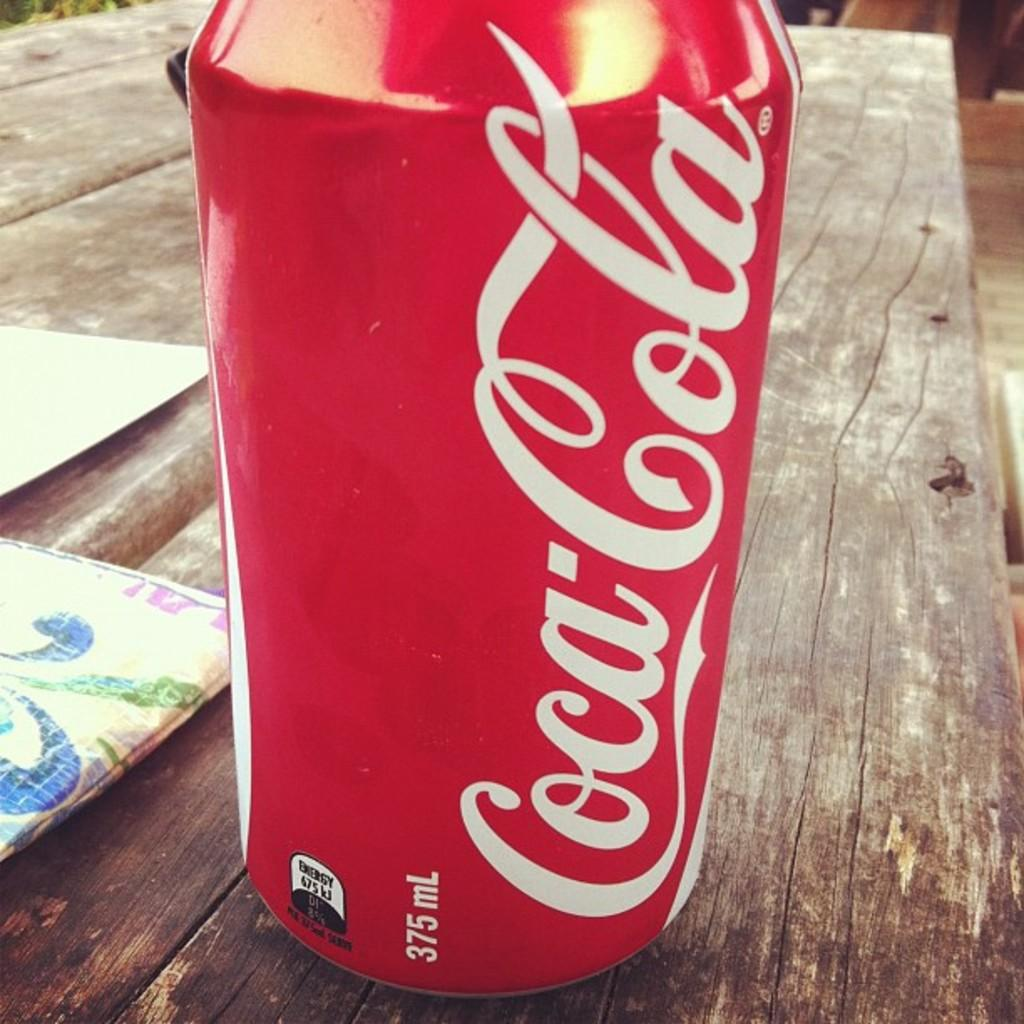<image>
Write a terse but informative summary of the picture. a red aluminum can of coca cola soda on a wooden table 